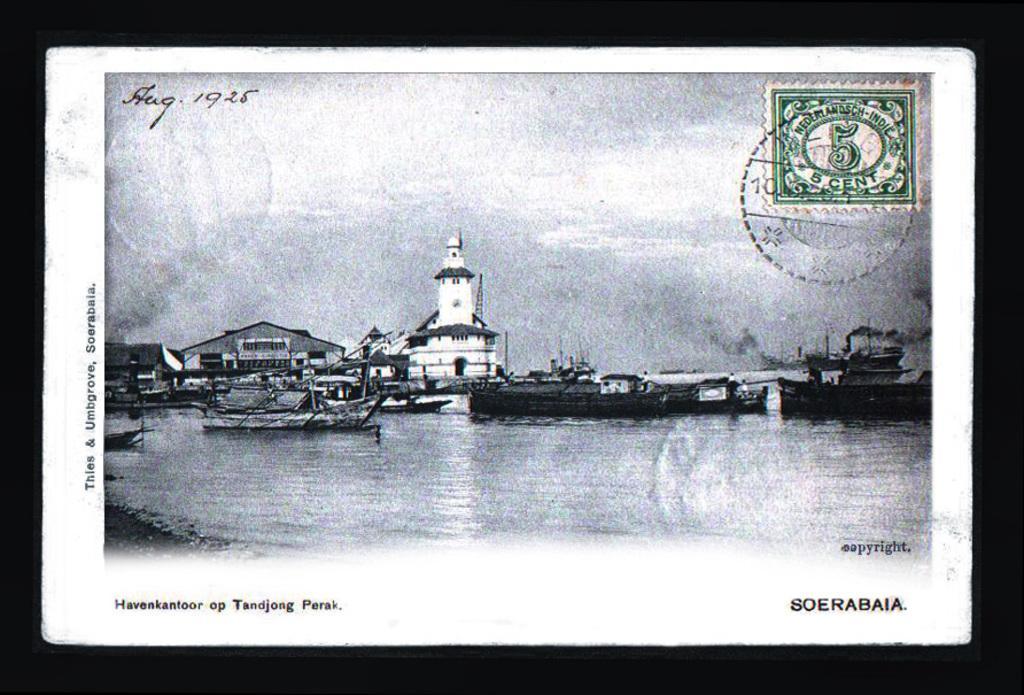Describe this image in one or two sentences. This is a black and white image, in this image in the center there is a lake. In that lake there are some ships and in the background there are some buildings, and at the top and bottom of the image there is some text. And on the right side of the image there is some stamp. 